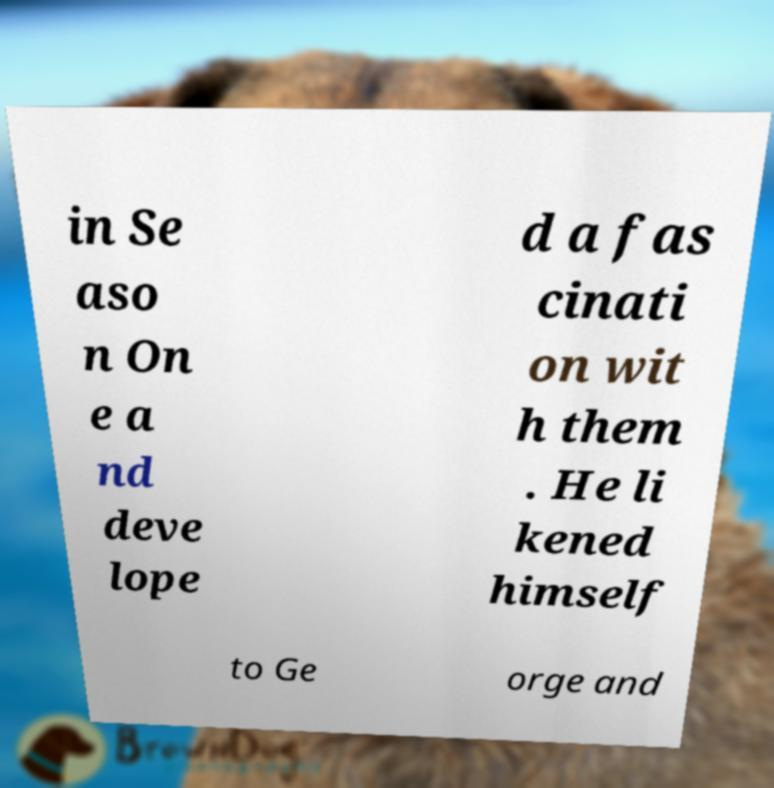There's text embedded in this image that I need extracted. Can you transcribe it verbatim? in Se aso n On e a nd deve lope d a fas cinati on wit h them . He li kened himself to Ge orge and 